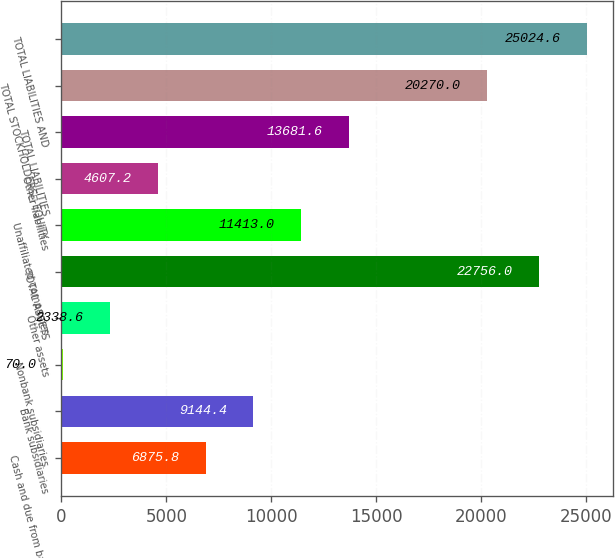<chart> <loc_0><loc_0><loc_500><loc_500><bar_chart><fcel>Cash and due from banks<fcel>Bank subsidiaries<fcel>Nonbank subsidiaries<fcel>Other assets<fcel>TOTAL ASSETS<fcel>Unaffiliated companies<fcel>Other liabilities<fcel>TOTAL LIABILITIES<fcel>TOTAL STOCKHOLDERS EQUITY<fcel>TOTAL LIABILITIES AND<nl><fcel>6875.8<fcel>9144.4<fcel>70<fcel>2338.6<fcel>22756<fcel>11413<fcel>4607.2<fcel>13681.6<fcel>20270<fcel>25024.6<nl></chart> 